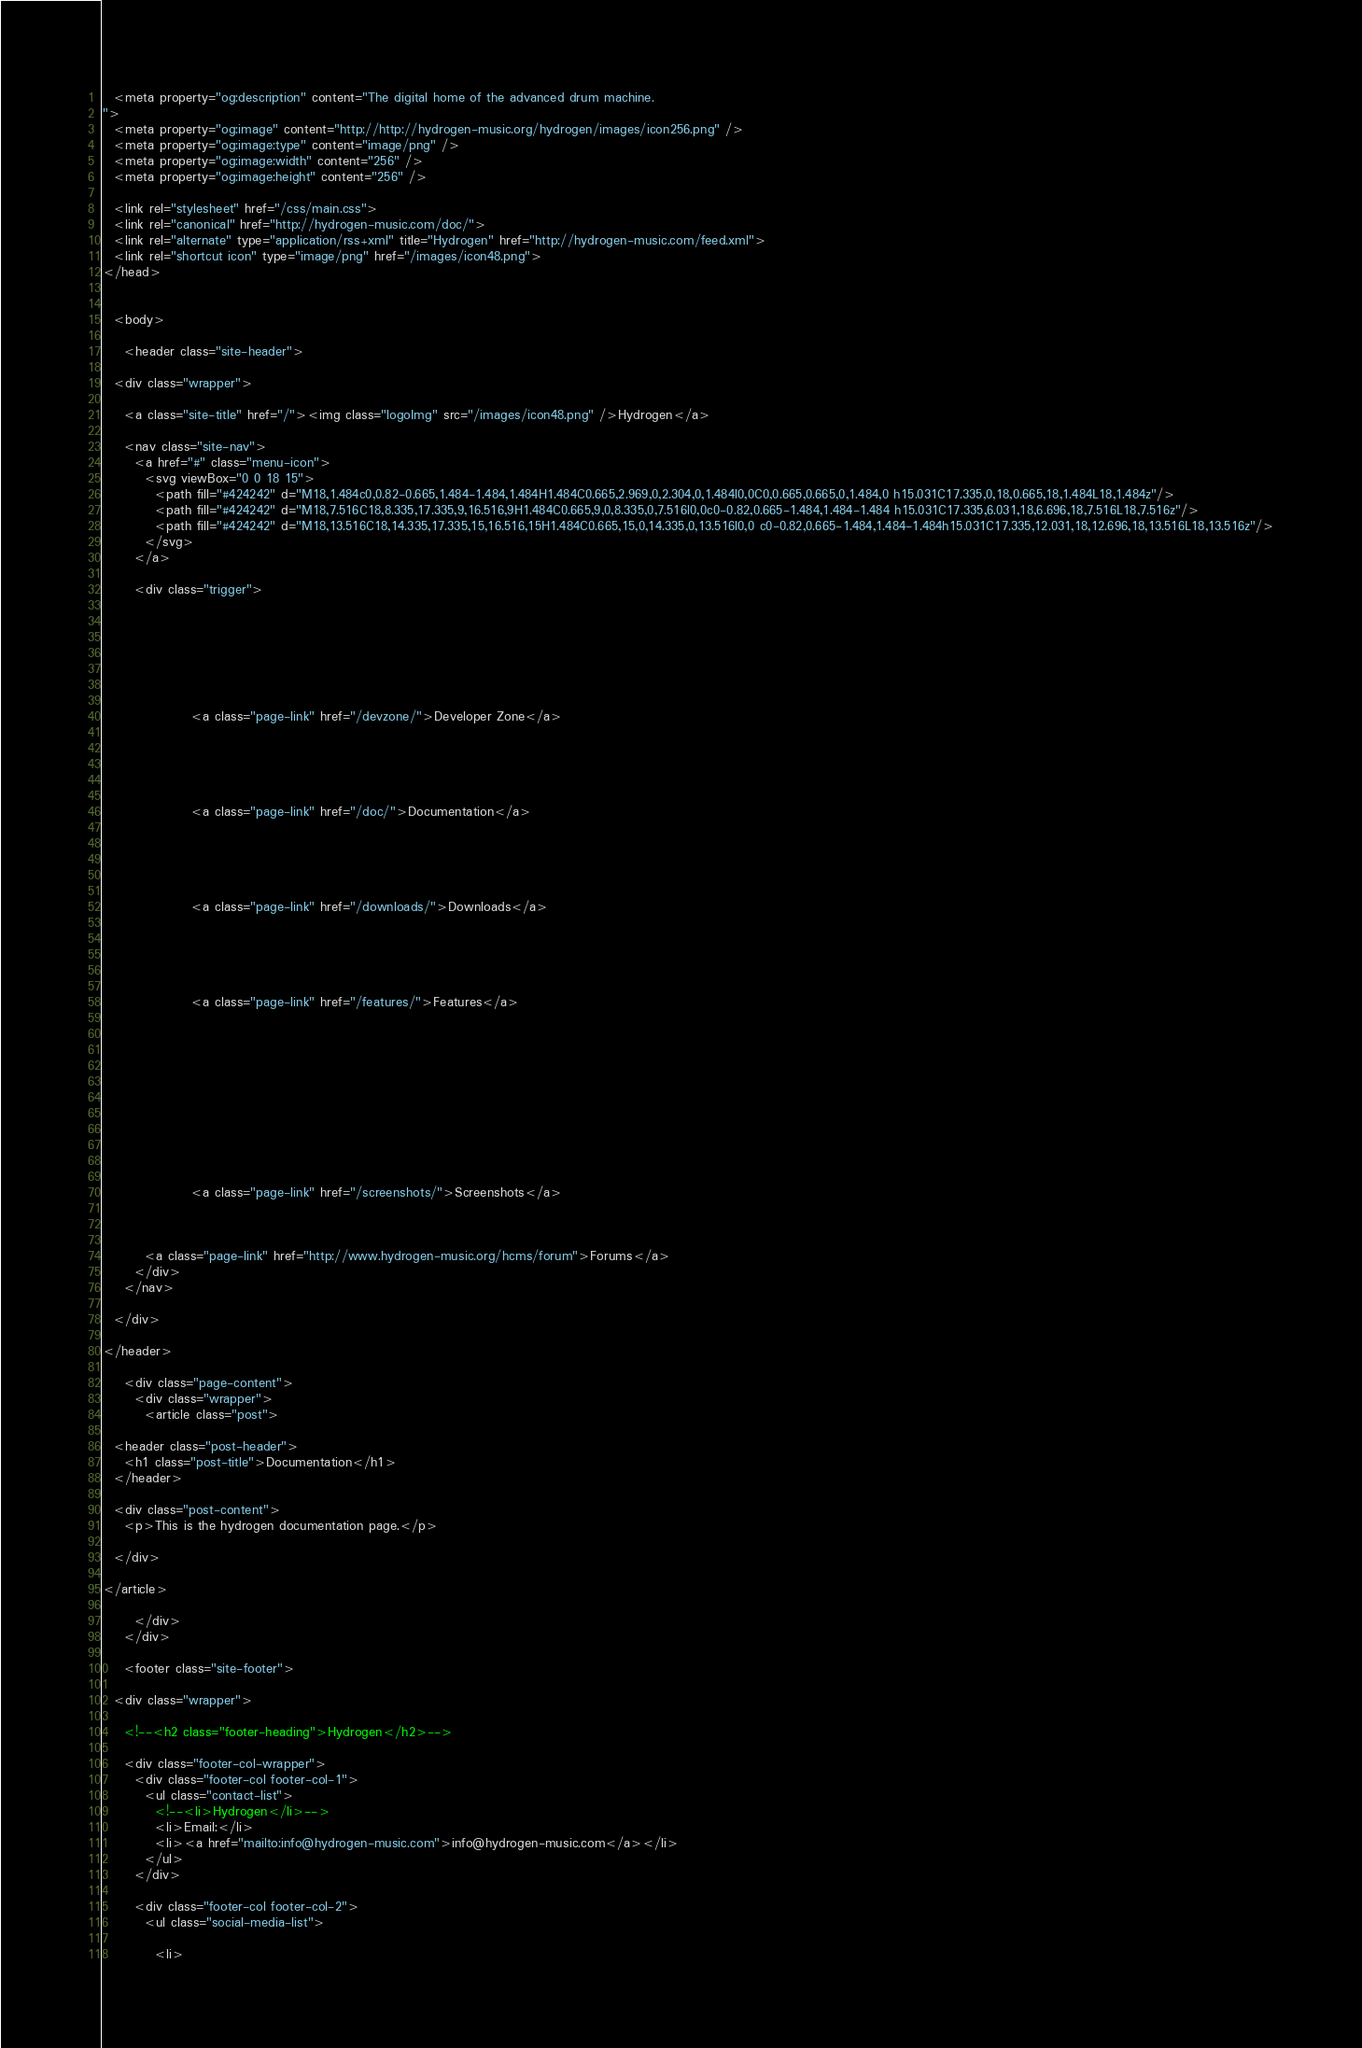Convert code to text. <code><loc_0><loc_0><loc_500><loc_500><_HTML_>  <meta property="og:description" content="The digital home of the advanced drum machine.
">
  <meta property="og:image" content="http://http://hydrogen-music.org/hydrogen/images/icon256.png" />
  <meta property="og:image:type" content="image/png" />
  <meta property="og:image:width" content="256" />
  <meta property="og:image:height" content="256" />

  <link rel="stylesheet" href="/css/main.css">
  <link rel="canonical" href="http://hydrogen-music.com/doc/">
  <link rel="alternate" type="application/rss+xml" title="Hydrogen" href="http://hydrogen-music.com/feed.xml">
  <link rel="shortcut icon" type="image/png" href="/images/icon48.png">
</head>


  <body>

    <header class="site-header">

  <div class="wrapper">

    <a class="site-title" href="/"><img class="logoImg" src="/images/icon48.png" />Hydrogen</a>

    <nav class="site-nav">
      <a href="#" class="menu-icon">
        <svg viewBox="0 0 18 15">
          <path fill="#424242" d="M18,1.484c0,0.82-0.665,1.484-1.484,1.484H1.484C0.665,2.969,0,2.304,0,1.484l0,0C0,0.665,0.665,0,1.484,0 h15.031C17.335,0,18,0.665,18,1.484L18,1.484z"/>
          <path fill="#424242" d="M18,7.516C18,8.335,17.335,9,16.516,9H1.484C0.665,9,0,8.335,0,7.516l0,0c0-0.82,0.665-1.484,1.484-1.484 h15.031C17.335,6.031,18,6.696,18,7.516L18,7.516z"/>
          <path fill="#424242" d="M18,13.516C18,14.335,17.335,15,16.516,15H1.484C0.665,15,0,14.335,0,13.516l0,0 c0-0.82,0.665-1.484,1.484-1.484h15.031C17.335,12.031,18,12.696,18,13.516L18,13.516z"/>
        </svg>
      </a>

      <div class="trigger">
        
          
			
          
        
          
			
				 <a class="page-link" href="/devzone/">Developer Zone</a>
			
          
        
          
			
				 <a class="page-link" href="/doc/">Documentation</a>
			
          
        
          
			
				 <a class="page-link" href="/downloads/">Downloads</a>
			
          
        
          
			
				 <a class="page-link" href="/features/">Features</a>
			
          
        
          
        
          
        
          
        
          
			
				 <a class="page-link" href="/screenshots/">Screenshots</a>
			
          
        
        <a class="page-link" href="http://www.hydrogen-music.org/hcms/forum">Forums</a>
      </div>
    </nav>

  </div>

</header>

    <div class="page-content">
      <div class="wrapper">
        <article class="post">

  <header class="post-header">
    <h1 class="post-title">Documentation</h1>
  </header>

  <div class="post-content">
    <p>This is the hydrogen documentation page.</p>

  </div>

</article>

      </div>
    </div>

    <footer class="site-footer">

  <div class="wrapper">

    <!--<h2 class="footer-heading">Hydrogen</h2>-->

    <div class="footer-col-wrapper">
      <div class="footer-col footer-col-1">
        <ul class="contact-list">
          <!--<li>Hydrogen</li>-->
          <li>Email:</li>
          <li><a href="mailto:info@hydrogen-music.com">info@hydrogen-music.com</a></li>
        </ul>
      </div>

      <div class="footer-col footer-col-2">
        <ul class="social-media-list">
          
          <li></code> 